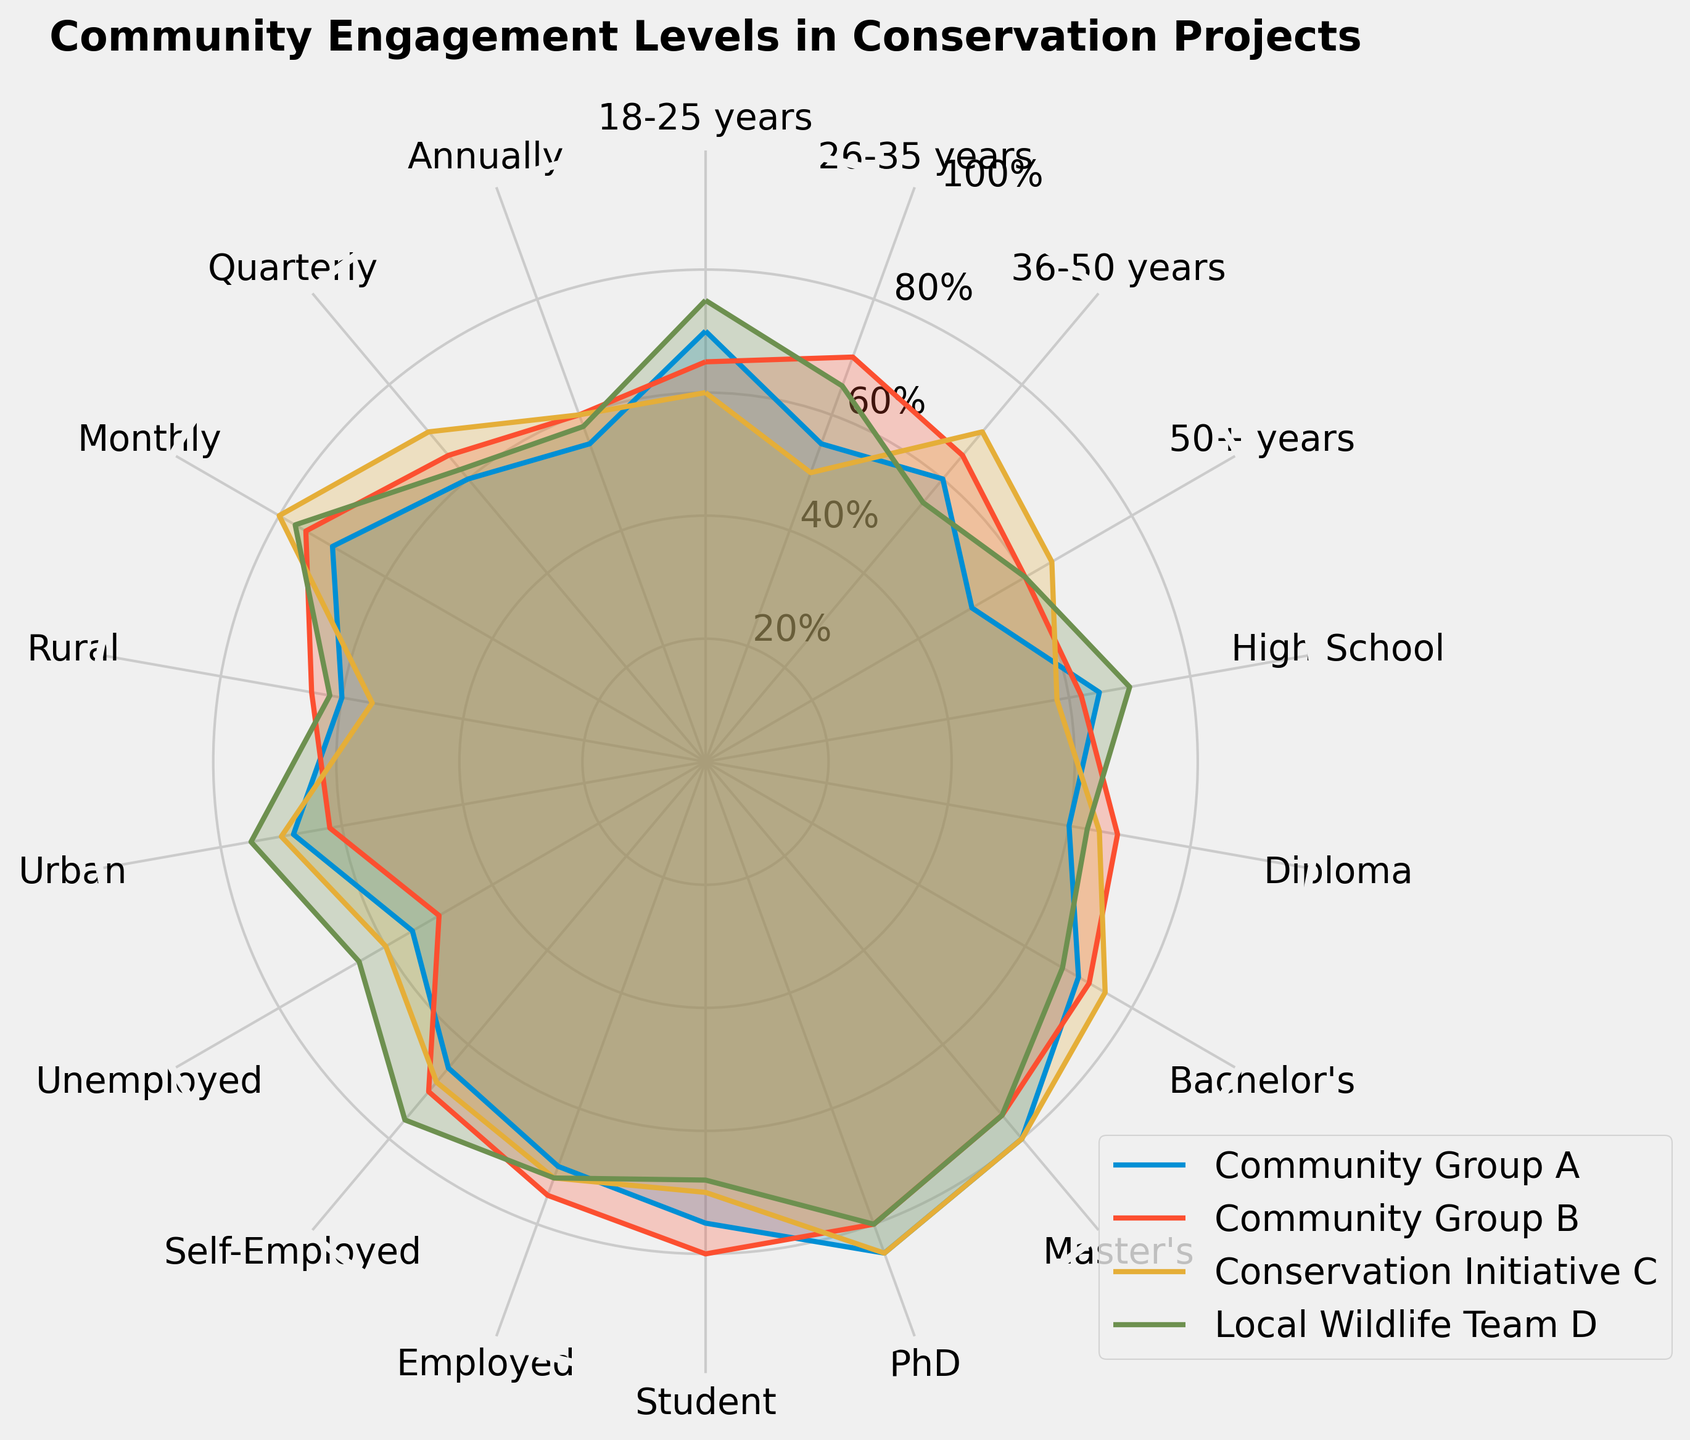What is the highest community engagement level for the 18-25 years group? Locate the 18-25 years group in the radar chart and identify the highest value among all community groups.
Answer: 75 (Local Wildlife Team D) Which community group engages the most participants with a PhD degree? Find the values for the PhD category for all community groups and compare them to identify the highest.
Answer: Conservation Initiative C What's the difference in engagement levels between Community Group A and Community Group B in the 'Urban' category? Find the engagement levels for Community Group A and Community Group B in the Urban category and calculate the difference (68 - 62).
Answer: 6 Which group has the lowest engagement level for the '50+ years' demographic? Compare the values for the 50+ years demographic for all community groups and identify the lowest value.
Answer: Community Group A Do Bachelor's degree holders have higher engagement with Community Group A or Local Wildlife Team D? Compare the engagement levels for Bachelor's degree holders for Community Group A and Local Wildlife Team D.
Answer: Community Group A How does the engagement of Self-Employed individuals compare between Community Group B and Conservation Initiative C? Find the values for Self-Employed individuals in both groups and compare them.
Answer: Community Group B has slightly higher engagement What's the average engagement level across all demographics for Community Group A? Sum all the engagement levels for Community Group A and divide by the number of categories (17 categories).
Answer: 64.41 Which community group shows the most variation in engagement levels across education levels? Visually inspect the plot to identify which community group has the most fluctuating values for the education categories (High School, Diploma, Bachelor's, Master's, PhD).
Answer: Conservation Initiative C What is the overall trend for community engagement levels from 'High School' to 'PhD' for Local Wildlife Team D? Examine the values for Local Wildlife Team D from 'High School' to 'PhD'.
Answer: Generally increasing 